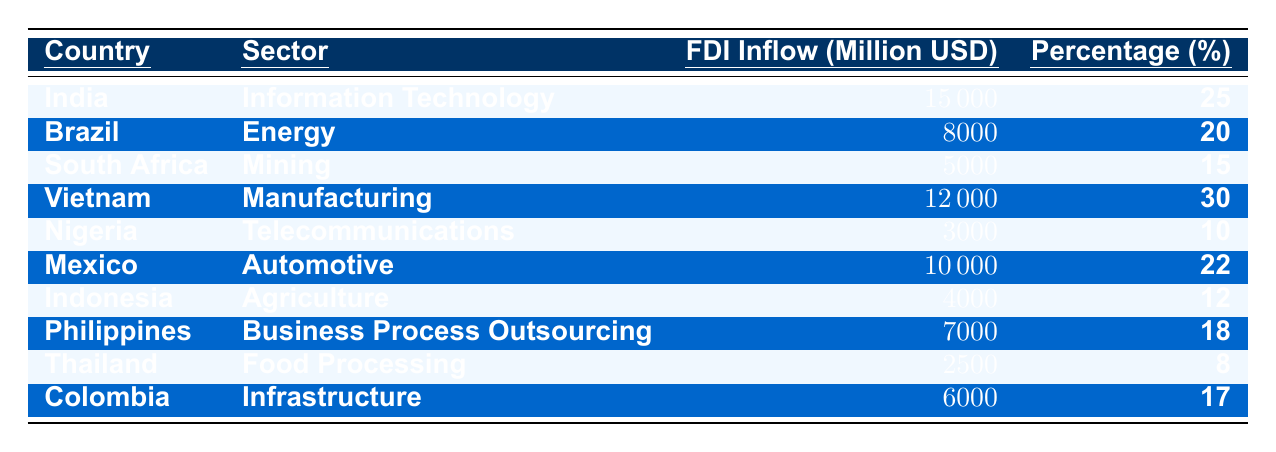What is the highest FDI inflow recorded in the table? By looking through the 'FDI Inflow (Million USD)' column in the table, India has the highest inflow at 15,000 million USD.
Answer: 15000 Which sector received the least FDI in the table? The sector with the least FDI inflow corresponds to Thailand, which is the Food Processing sector with an inflow of 2,500 million USD.
Answer: Food Processing What is the total FDI inflow for the Manufacturing sector? The Manufacturing sector's FDI inflow, which is from Vietnam, is 12,000 million USD. There are no other entries in this sector, making the total 12,000 million USD.
Answer: 12000 What percentage of total FDI inflow does the Telecommunications sector represent? The FDI inflow for the Telecommunications sector from Nigeria is 3,000 million USD. The total FDI inflows from all listed countries is 10,000 + 3,000 + 15,000 + 12,000 + 8,000 + 6,000 + 4,000 + 7,000 + 5,000 + 2,500 = 59,500 million USD. The percentage contribution of the Telecommunications sector is (3,000 / 59,500) * 100 ≈ 5.04%.
Answer: Approximately 5.04% How does the FDI inflow for Brazil's Energy sector compare to Vietnam's Manufacturing sector? Brazil's Energy sector has an FDI inflow of 8,000 million USD, while Vietnam's Manufacturing sector has an inflow of 12,000 million USD. The difference between them is 12,000 - 8,000 = 4,000 million USD, meaning Manufacturing has more inflow.
Answer: Manufacturing has 4,000 million USD more Which countries have an FDI inflow above 10,000 million USD? The countries with FDI inflows above 10,000 million USD are India (15,000 million USD) and Vietnam (12,000 million USD).
Answer: India and Vietnam What is the average FDI inflow across all sectors listed? Summing all the FDI inflow values gives 15,000 + 8,000 + 5,000 + 12,000 + 3,000 + 10,000 + 4,000 + 7,000 + 2,500 + 6,000 = 59,500 million USD. There are 10 sectors, so the average is 59,500 / 10 = 5,950 million USD.
Answer: 5950 Is it true that the FDI inflow in the Agriculture sector is greater than that in the Telecommunications sector? The FDI inflow for Agriculture (4,000 million USD) is greater than that for Telecommunications (3,000 million USD), which confirms the statement is true.
Answer: Yes What is the sector with the second-highest percentage of FDI inflow? By reviewing the percentages, Manufacturing has the highest at 30%, followed by Information Technology (25%), making it the second highest.
Answer: Information Technology 